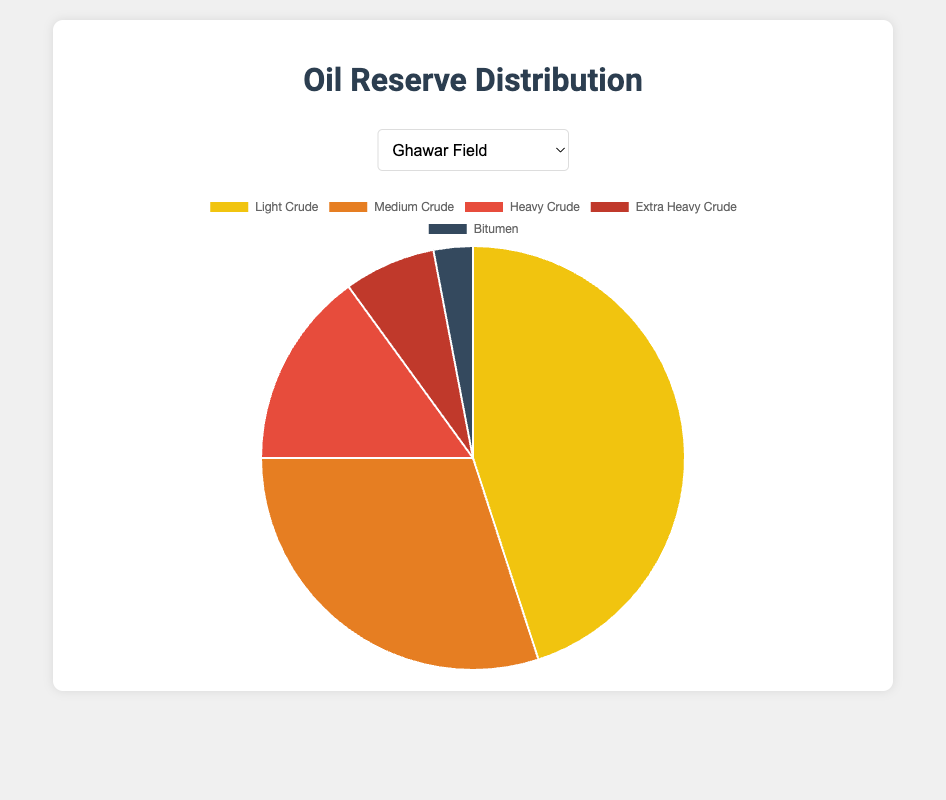What is the percentage of light crude oil in the Ghawar Field? The pie chart for the Ghawar Field shows the distribution of oil reserves. The light crude oil segment represents 45% of the total reserves.
Answer: 45% Which type of crude oil is the least prevalent in the Bakken Formation? By examining the pie chart for the Bakken Formation, we can see the smallest segment corresponds to extra heavy crude, with a percentage of 5%, equal to that of bitumen but with a smaller impact visually.
Answer: Extra heavy crude and bitumen How much greater is the percentage of medium crude oil in the Permian Basin than in the Orinoco Belt? The pie chart shows that the Permian Basin has 35% medium crude oil, while the Orinoco Belt has 20%. The difference is 35% - 20% = 15%.
Answer: 15% What is the difference in the percentage of heavy crude oil between the Athabasca Oil Sands and the Ghawar Field? The pie chart shows 25% heavy crude oil in the Athabasca Oil Sands and 15% in the Ghawar Field. The difference is 25% - 15% = 10%.
Answer: 10% Which field has the highest percentage of extra heavy crude oil, and what is that percentage? Observing the pie charts, the Orinoco Belt has the highest extra heavy crude oil percentage at 35%.
Answer: Orinoco Belt, 35% What percentage of the total reserves in the Permian Basin is accounted for by light and medium crude combined? From the pie chart, light crude oil accounts for 50% and medium crude for 35% in the Permian Basin. Combined, this is 50% + 35% = 85%.
Answer: 85% Which field exhibits the largest proportion of bitumen? The pie charts show the Athabasca Oil Sands have the highest bitumen percentage at 35%.
Answer: Athabasca Oil Sands In the Bakken Formation, what is the combined percentage of heavy and extra heavy crude oils? The chart for the Bakken Formation shows heavy crude with 10% and extra heavy crude with 5%. Combined, this equals 10% + 5% = 15%.
Answer: 15% Is the percentage of light crude oil in the Ghawar Field greater than or less than that in the Permian Basin? The Ghawar Field pie chart shows 45% light crude, while the Permian Basin chart shows 50%. This means 45% is less than 50%.
Answer: Less than How does the proportion of bitumen in the Orinoco Belt compare to that in the Bakken Formation? The pie chart shows both the Orinoco Belt and Bakken Formation have 5% bitumen, meaning they have equal proportions.
Answer: Equal 